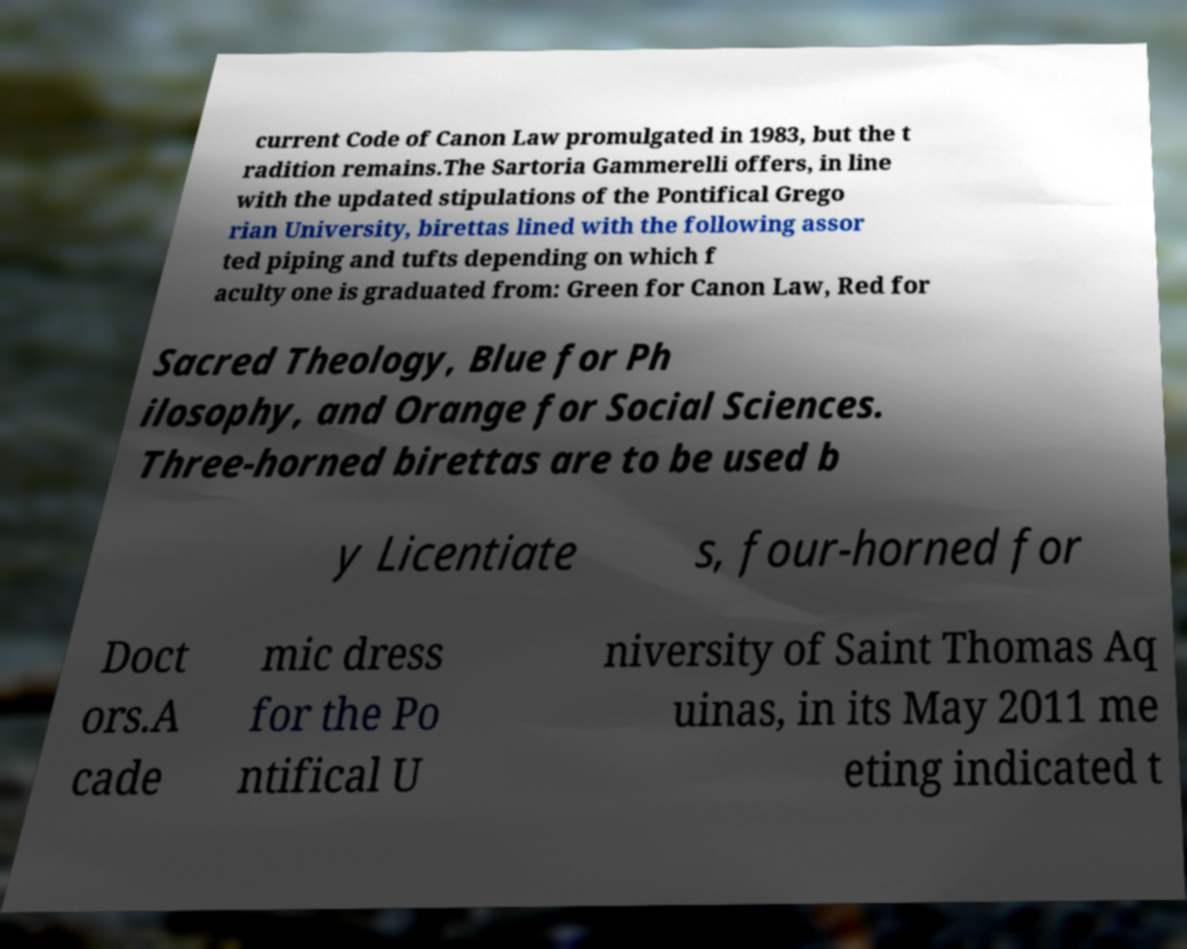There's text embedded in this image that I need extracted. Can you transcribe it verbatim? current Code of Canon Law promulgated in 1983, but the t radition remains.The Sartoria Gammerelli offers, in line with the updated stipulations of the Pontifical Grego rian University, birettas lined with the following assor ted piping and tufts depending on which f aculty one is graduated from: Green for Canon Law, Red for Sacred Theology, Blue for Ph ilosophy, and Orange for Social Sciences. Three-horned birettas are to be used b y Licentiate s, four-horned for Doct ors.A cade mic dress for the Po ntifical U niversity of Saint Thomas Aq uinas, in its May 2011 me eting indicated t 